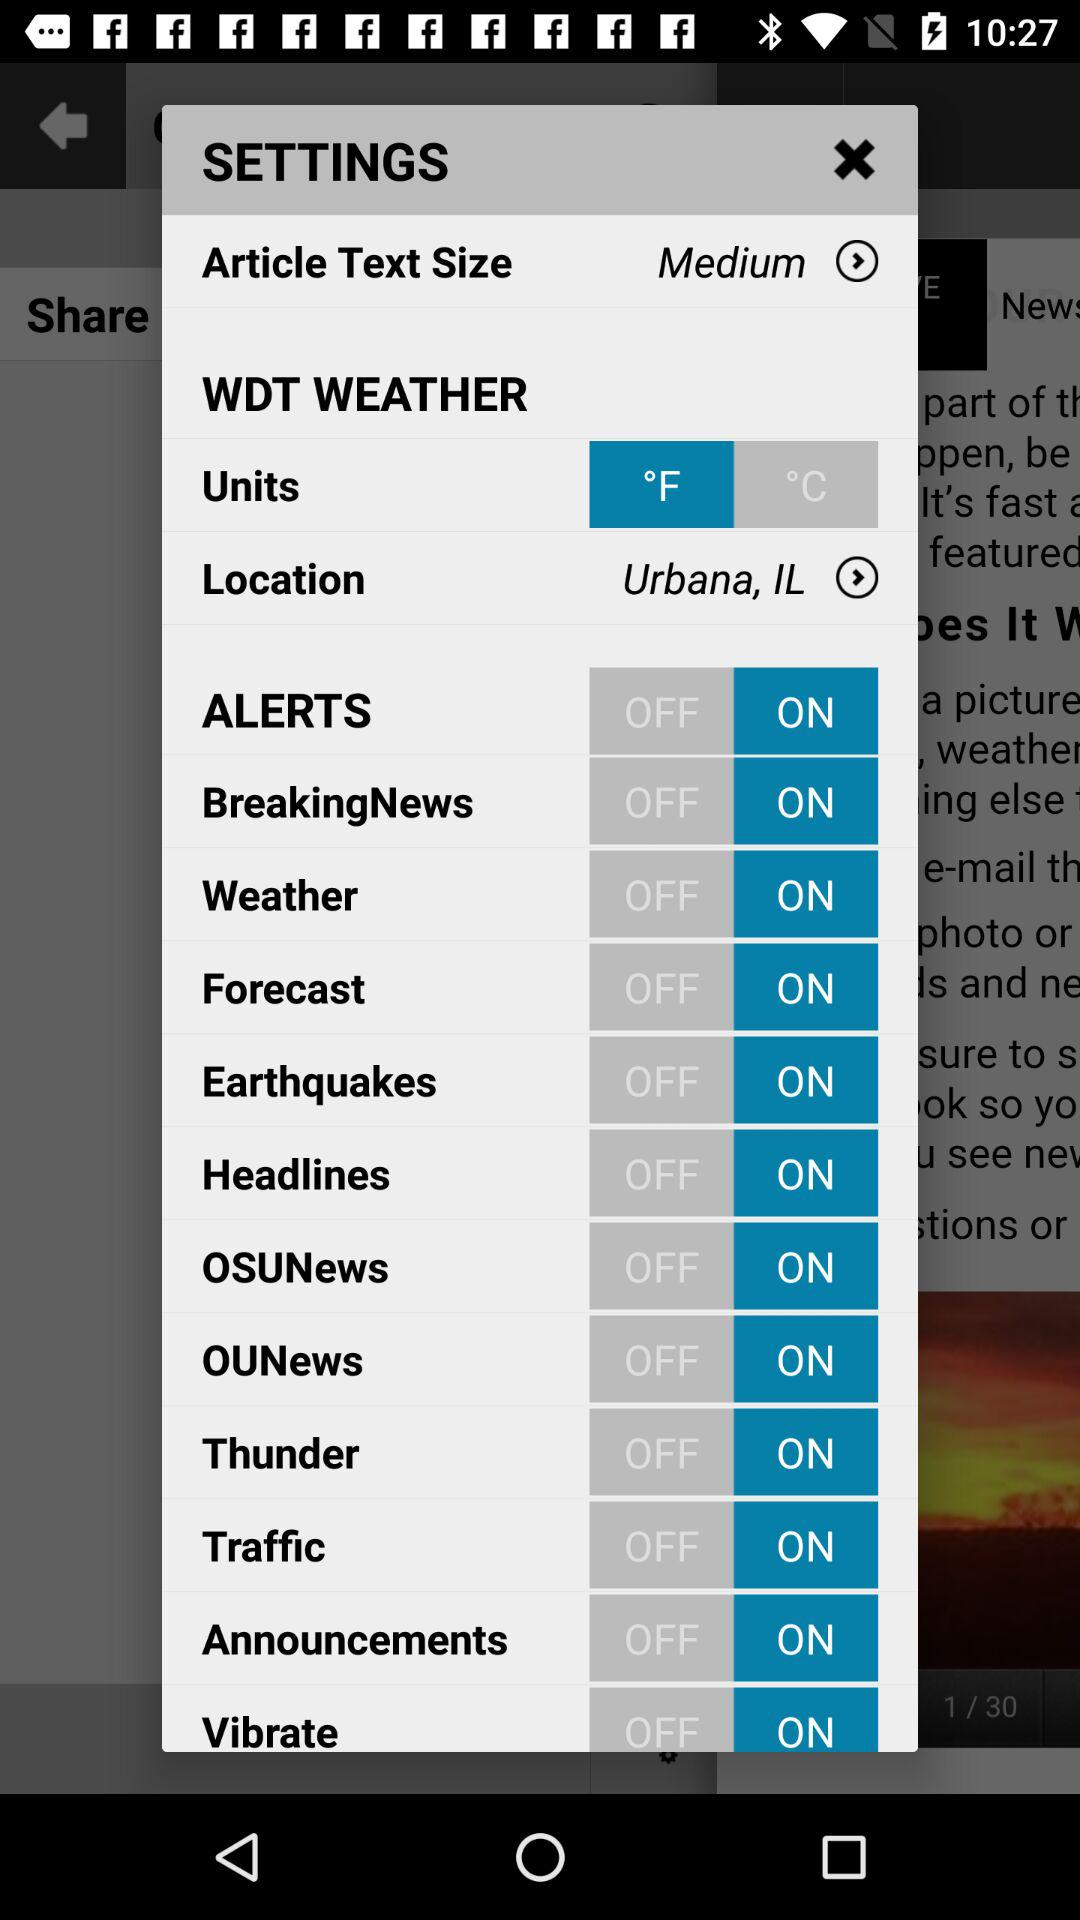What is the status of "Traffic"? The status is "on". 